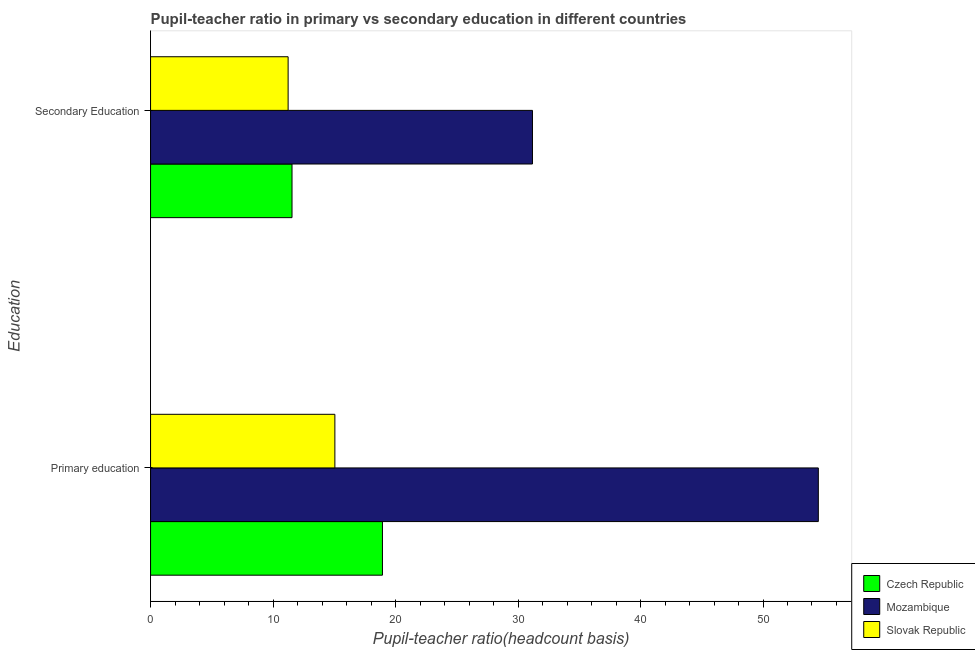How many groups of bars are there?
Provide a short and direct response. 2. Are the number of bars per tick equal to the number of legend labels?
Give a very brief answer. Yes. Are the number of bars on each tick of the Y-axis equal?
Make the answer very short. Yes. What is the pupil teacher ratio on secondary education in Mozambique?
Your answer should be very brief. 31.18. Across all countries, what is the maximum pupil-teacher ratio in primary education?
Your response must be concise. 54.52. Across all countries, what is the minimum pupil-teacher ratio in primary education?
Keep it short and to the point. 15.05. In which country was the pupil teacher ratio on secondary education maximum?
Provide a succinct answer. Mozambique. In which country was the pupil teacher ratio on secondary education minimum?
Make the answer very short. Slovak Republic. What is the total pupil-teacher ratio in primary education in the graph?
Your answer should be very brief. 88.5. What is the difference between the pupil teacher ratio on secondary education in Mozambique and that in Slovak Republic?
Offer a very short reply. 19.95. What is the difference between the pupil-teacher ratio in primary education in Czech Republic and the pupil teacher ratio on secondary education in Slovak Republic?
Provide a succinct answer. 7.7. What is the average pupil teacher ratio on secondary education per country?
Give a very brief answer. 17.99. What is the difference between the pupil teacher ratio on secondary education and pupil-teacher ratio in primary education in Slovak Republic?
Ensure brevity in your answer.  -3.82. What is the ratio of the pupil teacher ratio on secondary education in Slovak Republic to that in Mozambique?
Keep it short and to the point. 0.36. Is the pupil-teacher ratio in primary education in Slovak Republic less than that in Czech Republic?
Provide a succinct answer. Yes. What does the 3rd bar from the top in Primary education represents?
Your answer should be very brief. Czech Republic. What does the 2nd bar from the bottom in Secondary Education represents?
Keep it short and to the point. Mozambique. How many bars are there?
Offer a terse response. 6. What is the difference between two consecutive major ticks on the X-axis?
Offer a terse response. 10. Are the values on the major ticks of X-axis written in scientific E-notation?
Your response must be concise. No. How are the legend labels stacked?
Your response must be concise. Vertical. What is the title of the graph?
Ensure brevity in your answer.  Pupil-teacher ratio in primary vs secondary education in different countries. Does "Isle of Man" appear as one of the legend labels in the graph?
Offer a terse response. No. What is the label or title of the X-axis?
Keep it short and to the point. Pupil-teacher ratio(headcount basis). What is the label or title of the Y-axis?
Your answer should be compact. Education. What is the Pupil-teacher ratio(headcount basis) in Czech Republic in Primary education?
Give a very brief answer. 18.93. What is the Pupil-teacher ratio(headcount basis) of Mozambique in Primary education?
Your response must be concise. 54.52. What is the Pupil-teacher ratio(headcount basis) in Slovak Republic in Primary education?
Make the answer very short. 15.05. What is the Pupil-teacher ratio(headcount basis) of Czech Republic in Secondary Education?
Provide a short and direct response. 11.55. What is the Pupil-teacher ratio(headcount basis) of Mozambique in Secondary Education?
Your answer should be very brief. 31.18. What is the Pupil-teacher ratio(headcount basis) of Slovak Republic in Secondary Education?
Your response must be concise. 11.23. Across all Education, what is the maximum Pupil-teacher ratio(headcount basis) of Czech Republic?
Provide a short and direct response. 18.93. Across all Education, what is the maximum Pupil-teacher ratio(headcount basis) of Mozambique?
Offer a very short reply. 54.52. Across all Education, what is the maximum Pupil-teacher ratio(headcount basis) in Slovak Republic?
Your answer should be compact. 15.05. Across all Education, what is the minimum Pupil-teacher ratio(headcount basis) of Czech Republic?
Your response must be concise. 11.55. Across all Education, what is the minimum Pupil-teacher ratio(headcount basis) in Mozambique?
Your response must be concise. 31.18. Across all Education, what is the minimum Pupil-teacher ratio(headcount basis) of Slovak Republic?
Ensure brevity in your answer.  11.23. What is the total Pupil-teacher ratio(headcount basis) in Czech Republic in the graph?
Give a very brief answer. 30.48. What is the total Pupil-teacher ratio(headcount basis) in Mozambique in the graph?
Keep it short and to the point. 85.7. What is the total Pupil-teacher ratio(headcount basis) of Slovak Republic in the graph?
Offer a very short reply. 26.28. What is the difference between the Pupil-teacher ratio(headcount basis) in Czech Republic in Primary education and that in Secondary Education?
Your response must be concise. 7.38. What is the difference between the Pupil-teacher ratio(headcount basis) in Mozambique in Primary education and that in Secondary Education?
Offer a very short reply. 23.34. What is the difference between the Pupil-teacher ratio(headcount basis) in Slovak Republic in Primary education and that in Secondary Education?
Provide a succinct answer. 3.82. What is the difference between the Pupil-teacher ratio(headcount basis) of Czech Republic in Primary education and the Pupil-teacher ratio(headcount basis) of Mozambique in Secondary Education?
Keep it short and to the point. -12.25. What is the difference between the Pupil-teacher ratio(headcount basis) in Czech Republic in Primary education and the Pupil-teacher ratio(headcount basis) in Slovak Republic in Secondary Education?
Provide a short and direct response. 7.7. What is the difference between the Pupil-teacher ratio(headcount basis) of Mozambique in Primary education and the Pupil-teacher ratio(headcount basis) of Slovak Republic in Secondary Education?
Keep it short and to the point. 43.29. What is the average Pupil-teacher ratio(headcount basis) in Czech Republic per Education?
Give a very brief answer. 15.24. What is the average Pupil-teacher ratio(headcount basis) in Mozambique per Education?
Give a very brief answer. 42.85. What is the average Pupil-teacher ratio(headcount basis) of Slovak Republic per Education?
Offer a very short reply. 13.14. What is the difference between the Pupil-teacher ratio(headcount basis) in Czech Republic and Pupil-teacher ratio(headcount basis) in Mozambique in Primary education?
Provide a short and direct response. -35.59. What is the difference between the Pupil-teacher ratio(headcount basis) in Czech Republic and Pupil-teacher ratio(headcount basis) in Slovak Republic in Primary education?
Offer a terse response. 3.88. What is the difference between the Pupil-teacher ratio(headcount basis) of Mozambique and Pupil-teacher ratio(headcount basis) of Slovak Republic in Primary education?
Give a very brief answer. 39.47. What is the difference between the Pupil-teacher ratio(headcount basis) of Czech Republic and Pupil-teacher ratio(headcount basis) of Mozambique in Secondary Education?
Offer a terse response. -19.63. What is the difference between the Pupil-teacher ratio(headcount basis) in Czech Republic and Pupil-teacher ratio(headcount basis) in Slovak Republic in Secondary Education?
Ensure brevity in your answer.  0.32. What is the difference between the Pupil-teacher ratio(headcount basis) in Mozambique and Pupil-teacher ratio(headcount basis) in Slovak Republic in Secondary Education?
Your response must be concise. 19.95. What is the ratio of the Pupil-teacher ratio(headcount basis) of Czech Republic in Primary education to that in Secondary Education?
Keep it short and to the point. 1.64. What is the ratio of the Pupil-teacher ratio(headcount basis) of Mozambique in Primary education to that in Secondary Education?
Make the answer very short. 1.75. What is the ratio of the Pupil-teacher ratio(headcount basis) of Slovak Republic in Primary education to that in Secondary Education?
Keep it short and to the point. 1.34. What is the difference between the highest and the second highest Pupil-teacher ratio(headcount basis) in Czech Republic?
Offer a terse response. 7.38. What is the difference between the highest and the second highest Pupil-teacher ratio(headcount basis) in Mozambique?
Your answer should be compact. 23.34. What is the difference between the highest and the second highest Pupil-teacher ratio(headcount basis) of Slovak Republic?
Your answer should be compact. 3.82. What is the difference between the highest and the lowest Pupil-teacher ratio(headcount basis) in Czech Republic?
Offer a terse response. 7.38. What is the difference between the highest and the lowest Pupil-teacher ratio(headcount basis) of Mozambique?
Ensure brevity in your answer.  23.34. What is the difference between the highest and the lowest Pupil-teacher ratio(headcount basis) in Slovak Republic?
Keep it short and to the point. 3.82. 